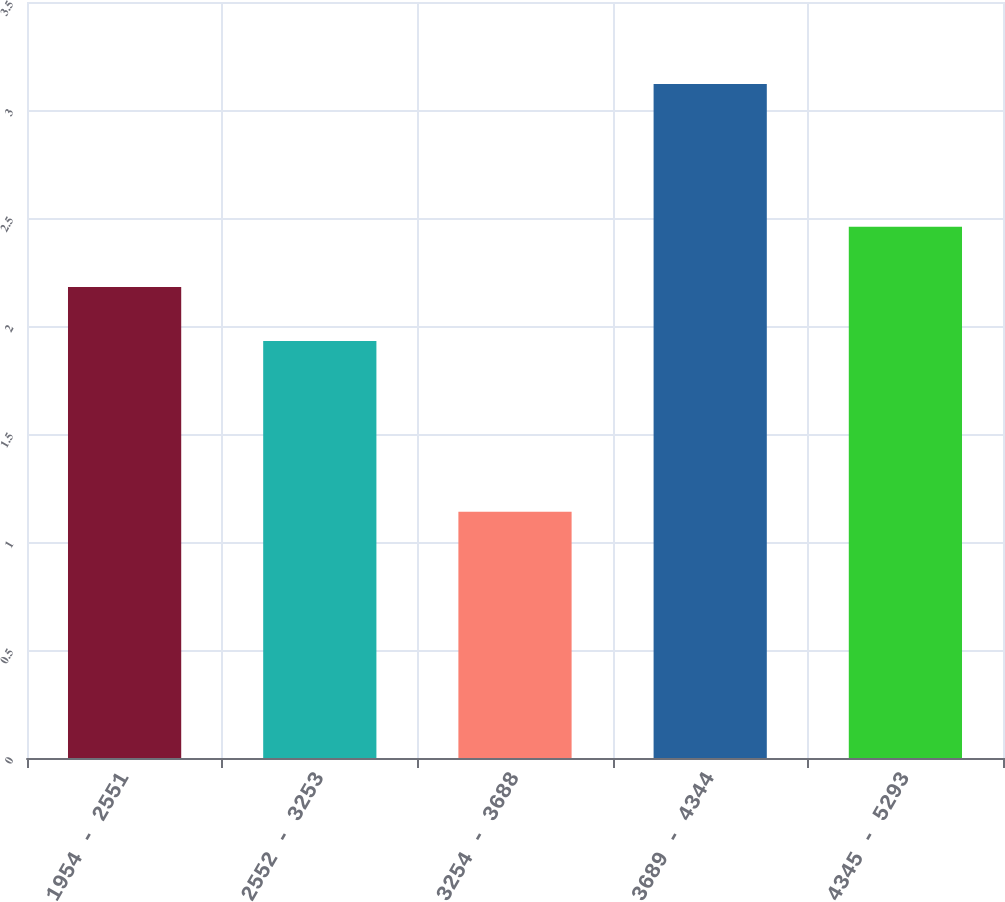Convert chart. <chart><loc_0><loc_0><loc_500><loc_500><bar_chart><fcel>1954 - 2551<fcel>2552 - 3253<fcel>3254 - 3688<fcel>3689 - 4344<fcel>4345 - 5293<nl><fcel>2.18<fcel>1.93<fcel>1.14<fcel>3.12<fcel>2.46<nl></chart> 